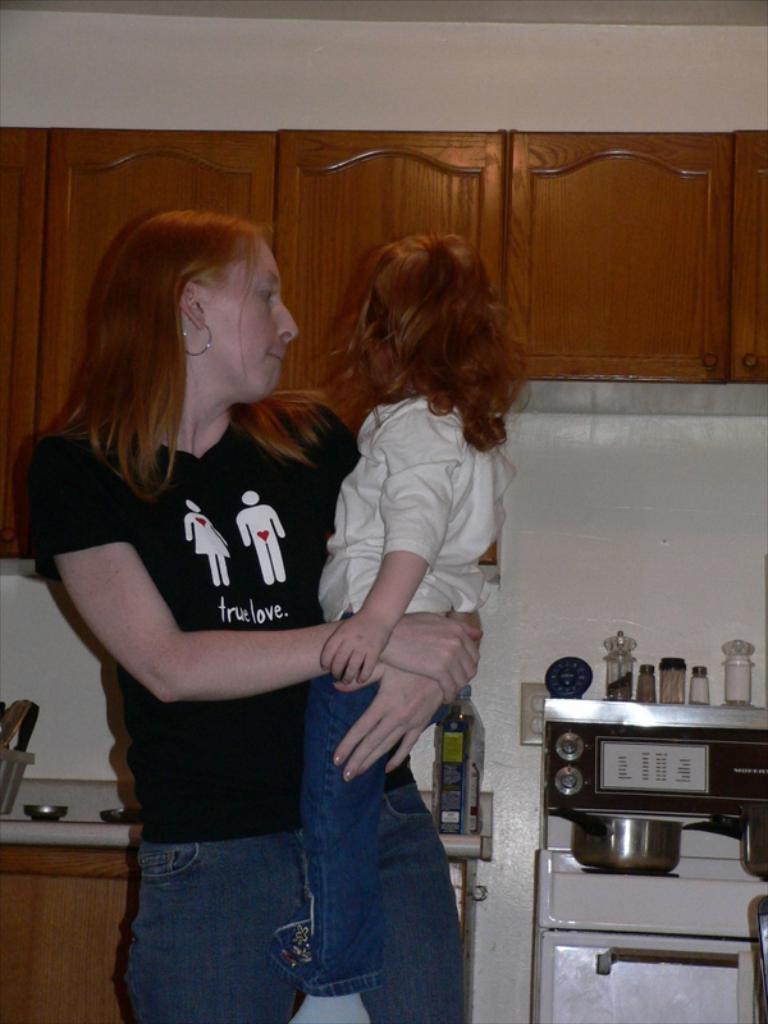What does the woman's shirt say?
Ensure brevity in your answer.  True love. Does she believe in true love?
Offer a very short reply. Yes. 